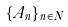Convert formula to latex. <formula><loc_0><loc_0><loc_500><loc_500>\{ A _ { n } \} _ { n \in N }</formula> 